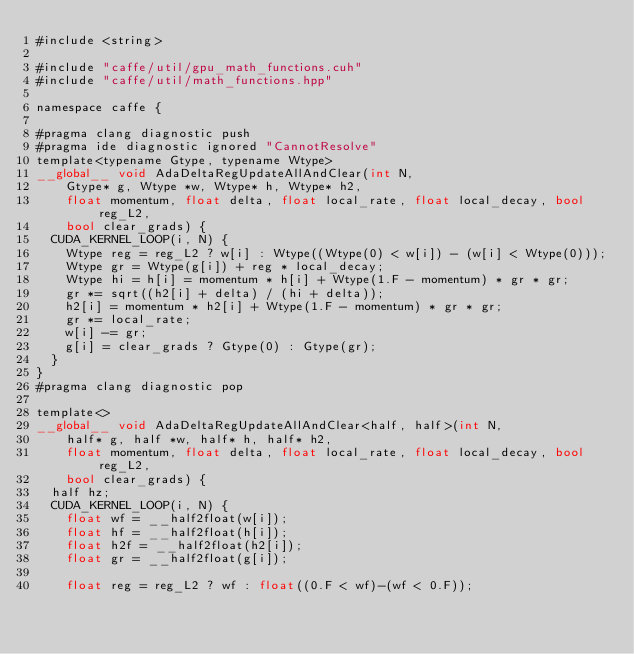Convert code to text. <code><loc_0><loc_0><loc_500><loc_500><_Cuda_>#include <string>

#include "caffe/util/gpu_math_functions.cuh"
#include "caffe/util/math_functions.hpp"

namespace caffe {

#pragma clang diagnostic push
#pragma ide diagnostic ignored "CannotResolve"
template<typename Gtype, typename Wtype>
__global__ void AdaDeltaRegUpdateAllAndClear(int N,
    Gtype* g, Wtype *w, Wtype* h, Wtype* h2,
    float momentum, float delta, float local_rate, float local_decay, bool reg_L2,
    bool clear_grads) {
  CUDA_KERNEL_LOOP(i, N) {
    Wtype reg = reg_L2 ? w[i] : Wtype((Wtype(0) < w[i]) - (w[i] < Wtype(0)));
    Wtype gr = Wtype(g[i]) + reg * local_decay;
    Wtype hi = h[i] = momentum * h[i] + Wtype(1.F - momentum) * gr * gr;
    gr *= sqrt((h2[i] + delta) / (hi + delta));
    h2[i] = momentum * h2[i] + Wtype(1.F - momentum) * gr * gr;
    gr *= local_rate;
    w[i] -= gr;
    g[i] = clear_grads ? Gtype(0) : Gtype(gr);
  }
}
#pragma clang diagnostic pop

template<>
__global__ void AdaDeltaRegUpdateAllAndClear<half, half>(int N,
    half* g, half *w, half* h, half* h2,
    float momentum, float delta, float local_rate, float local_decay, bool reg_L2,
    bool clear_grads) {
  half hz;
  CUDA_KERNEL_LOOP(i, N) {
    float wf = __half2float(w[i]);
    float hf = __half2float(h[i]);
    float h2f = __half2float(h2[i]);
    float gr = __half2float(g[i]);

    float reg = reg_L2 ? wf : float((0.F < wf)-(wf < 0.F));</code> 